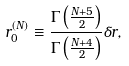<formula> <loc_0><loc_0><loc_500><loc_500>r _ { 0 } ^ { ( N ) } \equiv \frac { \Gamma \left ( \frac { N + 5 } { 2 } \right ) } { \Gamma \left ( \frac { N + 4 } { 2 } \right ) } \delta r ,</formula> 